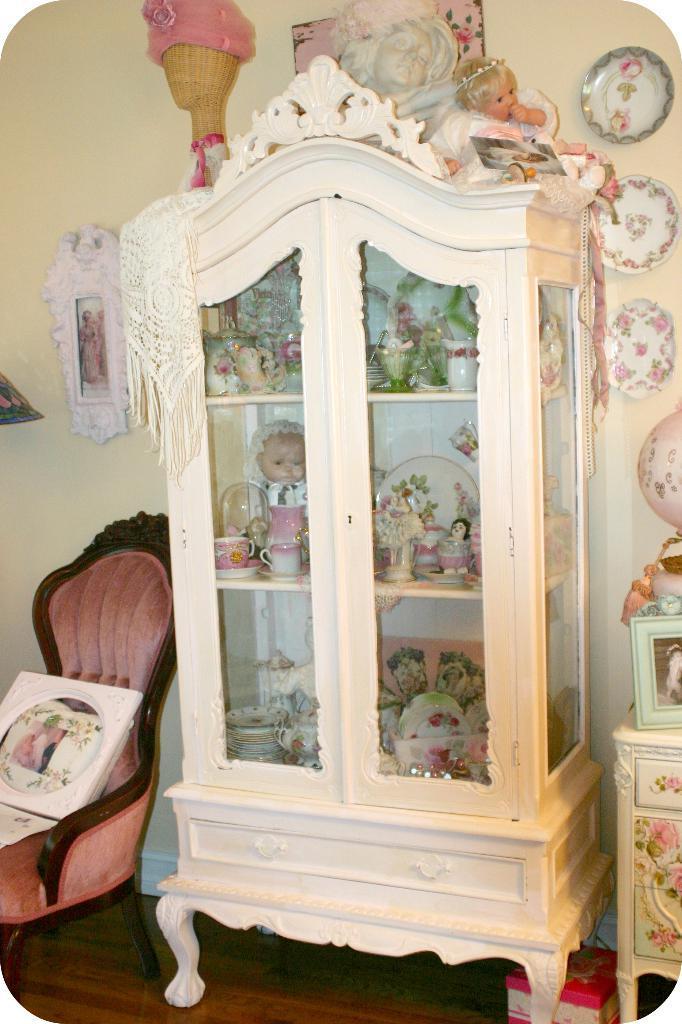How would you summarize this image in a sentence or two? In this image we can see the wooden shelf with toys, plates, cups, saucers and also plates. On the left there is a chair with the frame. On the right, we can see the frame on the table. There is a box on the floor. In the background we can see some plates, frame and also the wall. We can also see the depiction of a girl and also the toy at the top. 